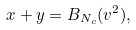<formula> <loc_0><loc_0><loc_500><loc_500>x + y = B _ { N _ { c } } ( v ^ { 2 } ) ,</formula> 